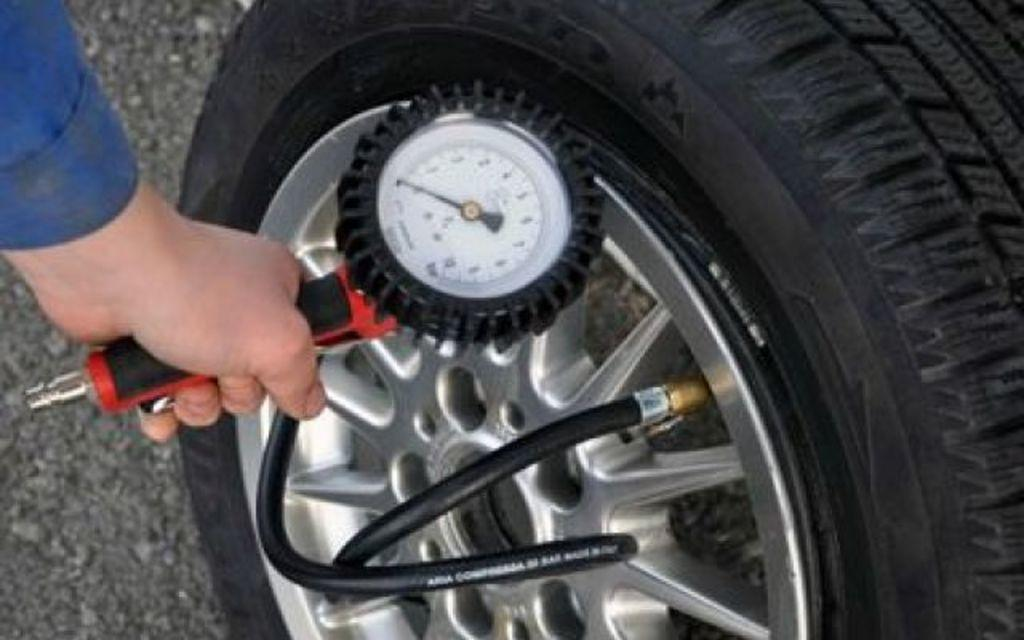What is the main subject of the image? There is a person in the image. What is the person holding in the image? The person is holding a pressure checking machine. Where is the pressure checking machine located in the image? The pressure checking machine is in the middle of the image. What can be seen on the right side of the image? There is a tire on the right side of the image. What type of skin condition can be seen on the person's face in the image? There is no indication of a skin condition on the person's face in the image. Is the person in the image a spy? There is no information in the image to suggest that the person is a spy. 